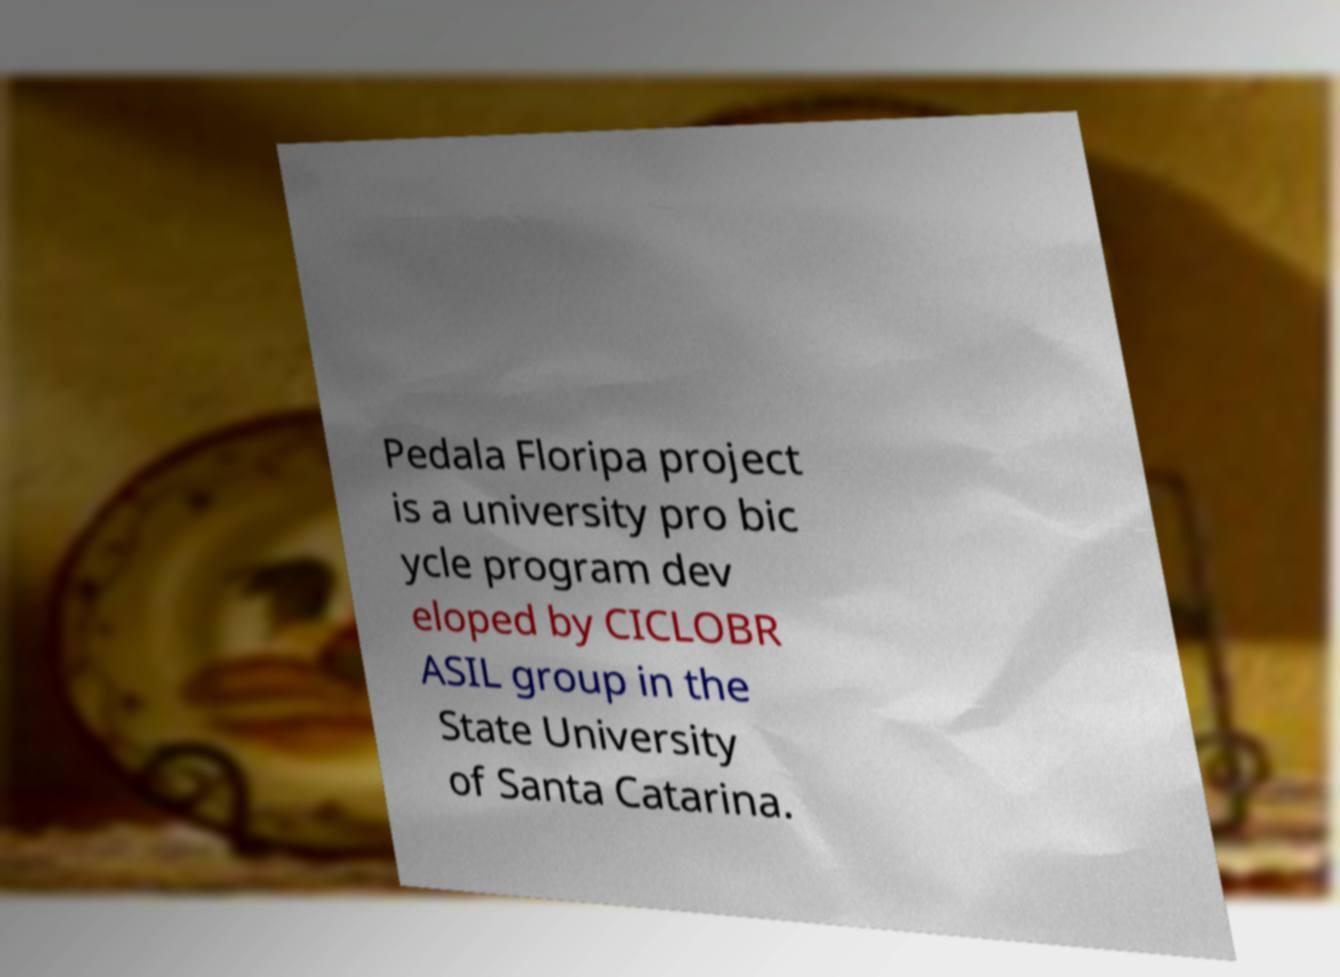For documentation purposes, I need the text within this image transcribed. Could you provide that? Pedala Floripa project is a university pro bic ycle program dev eloped by CICLOBR ASIL group in the State University of Santa Catarina. 